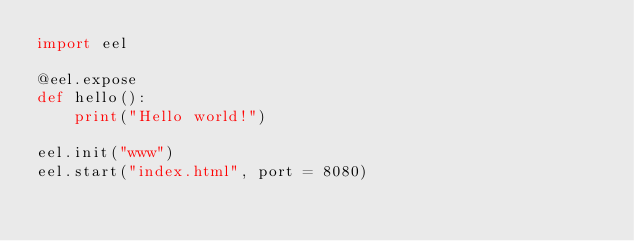<code> <loc_0><loc_0><loc_500><loc_500><_Python_>import eel

@eel.expose
def hello():
    print("Hello world!")

eel.init("www")
eel.start("index.html", port = 8080)</code> 